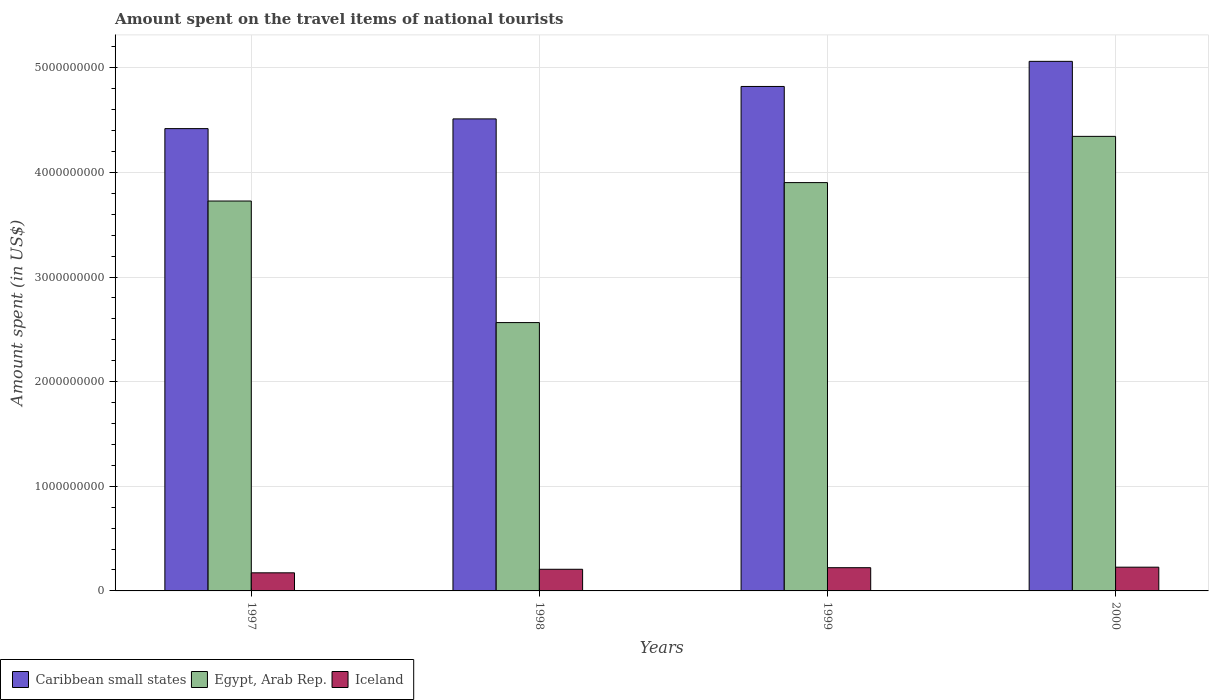How many different coloured bars are there?
Your answer should be very brief. 3. How many groups of bars are there?
Ensure brevity in your answer.  4. Are the number of bars on each tick of the X-axis equal?
Provide a short and direct response. Yes. How many bars are there on the 4th tick from the left?
Make the answer very short. 3. In how many cases, is the number of bars for a given year not equal to the number of legend labels?
Your answer should be compact. 0. What is the amount spent on the travel items of national tourists in Egypt, Arab Rep. in 1998?
Offer a terse response. 2.56e+09. Across all years, what is the maximum amount spent on the travel items of national tourists in Iceland?
Your response must be concise. 2.27e+08. Across all years, what is the minimum amount spent on the travel items of national tourists in Iceland?
Keep it short and to the point. 1.73e+08. In which year was the amount spent on the travel items of national tourists in Caribbean small states minimum?
Provide a succinct answer. 1997. What is the total amount spent on the travel items of national tourists in Egypt, Arab Rep. in the graph?
Your answer should be compact. 1.45e+1. What is the difference between the amount spent on the travel items of national tourists in Caribbean small states in 1998 and that in 2000?
Make the answer very short. -5.50e+08. What is the difference between the amount spent on the travel items of national tourists in Egypt, Arab Rep. in 2000 and the amount spent on the travel items of national tourists in Iceland in 1999?
Keep it short and to the point. 4.12e+09. What is the average amount spent on the travel items of national tourists in Egypt, Arab Rep. per year?
Give a very brief answer. 3.64e+09. In the year 1997, what is the difference between the amount spent on the travel items of national tourists in Caribbean small states and amount spent on the travel items of national tourists in Iceland?
Offer a terse response. 4.25e+09. What is the ratio of the amount spent on the travel items of national tourists in Egypt, Arab Rep. in 1997 to that in 2000?
Provide a short and direct response. 0.86. Is the amount spent on the travel items of national tourists in Iceland in 1999 less than that in 2000?
Your answer should be very brief. Yes. Is the difference between the amount spent on the travel items of national tourists in Caribbean small states in 1998 and 2000 greater than the difference between the amount spent on the travel items of national tourists in Iceland in 1998 and 2000?
Your answer should be very brief. No. What is the difference between the highest and the second highest amount spent on the travel items of national tourists in Iceland?
Provide a succinct answer. 5.00e+06. What is the difference between the highest and the lowest amount spent on the travel items of national tourists in Caribbean small states?
Make the answer very short. 6.43e+08. What does the 1st bar from the left in 1999 represents?
Provide a short and direct response. Caribbean small states. What does the 2nd bar from the right in 2000 represents?
Give a very brief answer. Egypt, Arab Rep. How many bars are there?
Keep it short and to the point. 12. Are the values on the major ticks of Y-axis written in scientific E-notation?
Offer a terse response. No. Does the graph contain any zero values?
Make the answer very short. No. Does the graph contain grids?
Offer a very short reply. Yes. Where does the legend appear in the graph?
Offer a terse response. Bottom left. What is the title of the graph?
Offer a very short reply. Amount spent on the travel items of national tourists. Does "Ireland" appear as one of the legend labels in the graph?
Your answer should be compact. No. What is the label or title of the X-axis?
Offer a very short reply. Years. What is the label or title of the Y-axis?
Provide a short and direct response. Amount spent (in US$). What is the Amount spent (in US$) of Caribbean small states in 1997?
Keep it short and to the point. 4.42e+09. What is the Amount spent (in US$) in Egypt, Arab Rep. in 1997?
Give a very brief answer. 3.73e+09. What is the Amount spent (in US$) in Iceland in 1997?
Provide a succinct answer. 1.73e+08. What is the Amount spent (in US$) of Caribbean small states in 1998?
Make the answer very short. 4.51e+09. What is the Amount spent (in US$) in Egypt, Arab Rep. in 1998?
Your response must be concise. 2.56e+09. What is the Amount spent (in US$) of Iceland in 1998?
Your answer should be very brief. 2.07e+08. What is the Amount spent (in US$) of Caribbean small states in 1999?
Offer a very short reply. 4.82e+09. What is the Amount spent (in US$) in Egypt, Arab Rep. in 1999?
Your answer should be very brief. 3.90e+09. What is the Amount spent (in US$) in Iceland in 1999?
Ensure brevity in your answer.  2.22e+08. What is the Amount spent (in US$) of Caribbean small states in 2000?
Offer a very short reply. 5.06e+09. What is the Amount spent (in US$) in Egypt, Arab Rep. in 2000?
Provide a succinct answer. 4.34e+09. What is the Amount spent (in US$) in Iceland in 2000?
Ensure brevity in your answer.  2.27e+08. Across all years, what is the maximum Amount spent (in US$) in Caribbean small states?
Your answer should be very brief. 5.06e+09. Across all years, what is the maximum Amount spent (in US$) of Egypt, Arab Rep.?
Your answer should be very brief. 4.34e+09. Across all years, what is the maximum Amount spent (in US$) of Iceland?
Offer a terse response. 2.27e+08. Across all years, what is the minimum Amount spent (in US$) of Caribbean small states?
Offer a very short reply. 4.42e+09. Across all years, what is the minimum Amount spent (in US$) in Egypt, Arab Rep.?
Keep it short and to the point. 2.56e+09. Across all years, what is the minimum Amount spent (in US$) in Iceland?
Your response must be concise. 1.73e+08. What is the total Amount spent (in US$) in Caribbean small states in the graph?
Ensure brevity in your answer.  1.88e+1. What is the total Amount spent (in US$) of Egypt, Arab Rep. in the graph?
Keep it short and to the point. 1.45e+1. What is the total Amount spent (in US$) in Iceland in the graph?
Make the answer very short. 8.29e+08. What is the difference between the Amount spent (in US$) of Caribbean small states in 1997 and that in 1998?
Keep it short and to the point. -9.30e+07. What is the difference between the Amount spent (in US$) of Egypt, Arab Rep. in 1997 and that in 1998?
Make the answer very short. 1.16e+09. What is the difference between the Amount spent (in US$) of Iceland in 1997 and that in 1998?
Ensure brevity in your answer.  -3.40e+07. What is the difference between the Amount spent (in US$) of Caribbean small states in 1997 and that in 1999?
Offer a very short reply. -4.03e+08. What is the difference between the Amount spent (in US$) of Egypt, Arab Rep. in 1997 and that in 1999?
Keep it short and to the point. -1.76e+08. What is the difference between the Amount spent (in US$) of Iceland in 1997 and that in 1999?
Your answer should be compact. -4.90e+07. What is the difference between the Amount spent (in US$) in Caribbean small states in 1997 and that in 2000?
Your response must be concise. -6.43e+08. What is the difference between the Amount spent (in US$) in Egypt, Arab Rep. in 1997 and that in 2000?
Offer a very short reply. -6.18e+08. What is the difference between the Amount spent (in US$) in Iceland in 1997 and that in 2000?
Your response must be concise. -5.40e+07. What is the difference between the Amount spent (in US$) in Caribbean small states in 1998 and that in 1999?
Ensure brevity in your answer.  -3.10e+08. What is the difference between the Amount spent (in US$) of Egypt, Arab Rep. in 1998 and that in 1999?
Provide a succinct answer. -1.34e+09. What is the difference between the Amount spent (in US$) of Iceland in 1998 and that in 1999?
Provide a succinct answer. -1.50e+07. What is the difference between the Amount spent (in US$) in Caribbean small states in 1998 and that in 2000?
Ensure brevity in your answer.  -5.50e+08. What is the difference between the Amount spent (in US$) in Egypt, Arab Rep. in 1998 and that in 2000?
Your answer should be very brief. -1.78e+09. What is the difference between the Amount spent (in US$) in Iceland in 1998 and that in 2000?
Keep it short and to the point. -2.00e+07. What is the difference between the Amount spent (in US$) of Caribbean small states in 1999 and that in 2000?
Keep it short and to the point. -2.40e+08. What is the difference between the Amount spent (in US$) in Egypt, Arab Rep. in 1999 and that in 2000?
Make the answer very short. -4.42e+08. What is the difference between the Amount spent (in US$) of Iceland in 1999 and that in 2000?
Give a very brief answer. -5.00e+06. What is the difference between the Amount spent (in US$) of Caribbean small states in 1997 and the Amount spent (in US$) of Egypt, Arab Rep. in 1998?
Provide a succinct answer. 1.85e+09. What is the difference between the Amount spent (in US$) of Caribbean small states in 1997 and the Amount spent (in US$) of Iceland in 1998?
Your answer should be very brief. 4.21e+09. What is the difference between the Amount spent (in US$) in Egypt, Arab Rep. in 1997 and the Amount spent (in US$) in Iceland in 1998?
Keep it short and to the point. 3.52e+09. What is the difference between the Amount spent (in US$) in Caribbean small states in 1997 and the Amount spent (in US$) in Egypt, Arab Rep. in 1999?
Provide a short and direct response. 5.16e+08. What is the difference between the Amount spent (in US$) of Caribbean small states in 1997 and the Amount spent (in US$) of Iceland in 1999?
Ensure brevity in your answer.  4.20e+09. What is the difference between the Amount spent (in US$) in Egypt, Arab Rep. in 1997 and the Amount spent (in US$) in Iceland in 1999?
Your answer should be very brief. 3.50e+09. What is the difference between the Amount spent (in US$) in Caribbean small states in 1997 and the Amount spent (in US$) in Egypt, Arab Rep. in 2000?
Your answer should be very brief. 7.40e+07. What is the difference between the Amount spent (in US$) of Caribbean small states in 1997 and the Amount spent (in US$) of Iceland in 2000?
Your response must be concise. 4.19e+09. What is the difference between the Amount spent (in US$) in Egypt, Arab Rep. in 1997 and the Amount spent (in US$) in Iceland in 2000?
Your answer should be very brief. 3.50e+09. What is the difference between the Amount spent (in US$) in Caribbean small states in 1998 and the Amount spent (in US$) in Egypt, Arab Rep. in 1999?
Your response must be concise. 6.09e+08. What is the difference between the Amount spent (in US$) in Caribbean small states in 1998 and the Amount spent (in US$) in Iceland in 1999?
Your answer should be very brief. 4.29e+09. What is the difference between the Amount spent (in US$) in Egypt, Arab Rep. in 1998 and the Amount spent (in US$) in Iceland in 1999?
Give a very brief answer. 2.34e+09. What is the difference between the Amount spent (in US$) of Caribbean small states in 1998 and the Amount spent (in US$) of Egypt, Arab Rep. in 2000?
Your response must be concise. 1.67e+08. What is the difference between the Amount spent (in US$) of Caribbean small states in 1998 and the Amount spent (in US$) of Iceland in 2000?
Offer a very short reply. 4.28e+09. What is the difference between the Amount spent (in US$) in Egypt, Arab Rep. in 1998 and the Amount spent (in US$) in Iceland in 2000?
Give a very brief answer. 2.34e+09. What is the difference between the Amount spent (in US$) of Caribbean small states in 1999 and the Amount spent (in US$) of Egypt, Arab Rep. in 2000?
Offer a terse response. 4.77e+08. What is the difference between the Amount spent (in US$) in Caribbean small states in 1999 and the Amount spent (in US$) in Iceland in 2000?
Keep it short and to the point. 4.60e+09. What is the difference between the Amount spent (in US$) of Egypt, Arab Rep. in 1999 and the Amount spent (in US$) of Iceland in 2000?
Make the answer very short. 3.68e+09. What is the average Amount spent (in US$) in Caribbean small states per year?
Ensure brevity in your answer.  4.70e+09. What is the average Amount spent (in US$) in Egypt, Arab Rep. per year?
Keep it short and to the point. 3.64e+09. What is the average Amount spent (in US$) of Iceland per year?
Keep it short and to the point. 2.07e+08. In the year 1997, what is the difference between the Amount spent (in US$) in Caribbean small states and Amount spent (in US$) in Egypt, Arab Rep.?
Make the answer very short. 6.92e+08. In the year 1997, what is the difference between the Amount spent (in US$) in Caribbean small states and Amount spent (in US$) in Iceland?
Your answer should be compact. 4.25e+09. In the year 1997, what is the difference between the Amount spent (in US$) of Egypt, Arab Rep. and Amount spent (in US$) of Iceland?
Offer a terse response. 3.55e+09. In the year 1998, what is the difference between the Amount spent (in US$) of Caribbean small states and Amount spent (in US$) of Egypt, Arab Rep.?
Give a very brief answer. 1.95e+09. In the year 1998, what is the difference between the Amount spent (in US$) in Caribbean small states and Amount spent (in US$) in Iceland?
Your response must be concise. 4.30e+09. In the year 1998, what is the difference between the Amount spent (in US$) in Egypt, Arab Rep. and Amount spent (in US$) in Iceland?
Your response must be concise. 2.36e+09. In the year 1999, what is the difference between the Amount spent (in US$) in Caribbean small states and Amount spent (in US$) in Egypt, Arab Rep.?
Give a very brief answer. 9.19e+08. In the year 1999, what is the difference between the Amount spent (in US$) of Caribbean small states and Amount spent (in US$) of Iceland?
Your response must be concise. 4.60e+09. In the year 1999, what is the difference between the Amount spent (in US$) of Egypt, Arab Rep. and Amount spent (in US$) of Iceland?
Offer a very short reply. 3.68e+09. In the year 2000, what is the difference between the Amount spent (in US$) of Caribbean small states and Amount spent (in US$) of Egypt, Arab Rep.?
Your answer should be very brief. 7.17e+08. In the year 2000, what is the difference between the Amount spent (in US$) in Caribbean small states and Amount spent (in US$) in Iceland?
Ensure brevity in your answer.  4.84e+09. In the year 2000, what is the difference between the Amount spent (in US$) of Egypt, Arab Rep. and Amount spent (in US$) of Iceland?
Offer a terse response. 4.12e+09. What is the ratio of the Amount spent (in US$) of Caribbean small states in 1997 to that in 1998?
Provide a short and direct response. 0.98. What is the ratio of the Amount spent (in US$) in Egypt, Arab Rep. in 1997 to that in 1998?
Your answer should be very brief. 1.45. What is the ratio of the Amount spent (in US$) in Iceland in 1997 to that in 1998?
Ensure brevity in your answer.  0.84. What is the ratio of the Amount spent (in US$) of Caribbean small states in 1997 to that in 1999?
Keep it short and to the point. 0.92. What is the ratio of the Amount spent (in US$) of Egypt, Arab Rep. in 1997 to that in 1999?
Make the answer very short. 0.95. What is the ratio of the Amount spent (in US$) of Iceland in 1997 to that in 1999?
Ensure brevity in your answer.  0.78. What is the ratio of the Amount spent (in US$) of Caribbean small states in 1997 to that in 2000?
Provide a succinct answer. 0.87. What is the ratio of the Amount spent (in US$) in Egypt, Arab Rep. in 1997 to that in 2000?
Offer a very short reply. 0.86. What is the ratio of the Amount spent (in US$) of Iceland in 1997 to that in 2000?
Offer a terse response. 0.76. What is the ratio of the Amount spent (in US$) of Caribbean small states in 1998 to that in 1999?
Offer a very short reply. 0.94. What is the ratio of the Amount spent (in US$) of Egypt, Arab Rep. in 1998 to that in 1999?
Provide a succinct answer. 0.66. What is the ratio of the Amount spent (in US$) in Iceland in 1998 to that in 1999?
Offer a very short reply. 0.93. What is the ratio of the Amount spent (in US$) in Caribbean small states in 1998 to that in 2000?
Give a very brief answer. 0.89. What is the ratio of the Amount spent (in US$) in Egypt, Arab Rep. in 1998 to that in 2000?
Offer a very short reply. 0.59. What is the ratio of the Amount spent (in US$) in Iceland in 1998 to that in 2000?
Provide a short and direct response. 0.91. What is the ratio of the Amount spent (in US$) of Caribbean small states in 1999 to that in 2000?
Make the answer very short. 0.95. What is the ratio of the Amount spent (in US$) in Egypt, Arab Rep. in 1999 to that in 2000?
Give a very brief answer. 0.9. What is the ratio of the Amount spent (in US$) of Iceland in 1999 to that in 2000?
Offer a terse response. 0.98. What is the difference between the highest and the second highest Amount spent (in US$) of Caribbean small states?
Your answer should be very brief. 2.40e+08. What is the difference between the highest and the second highest Amount spent (in US$) in Egypt, Arab Rep.?
Provide a succinct answer. 4.42e+08. What is the difference between the highest and the lowest Amount spent (in US$) of Caribbean small states?
Keep it short and to the point. 6.43e+08. What is the difference between the highest and the lowest Amount spent (in US$) of Egypt, Arab Rep.?
Your answer should be very brief. 1.78e+09. What is the difference between the highest and the lowest Amount spent (in US$) of Iceland?
Make the answer very short. 5.40e+07. 